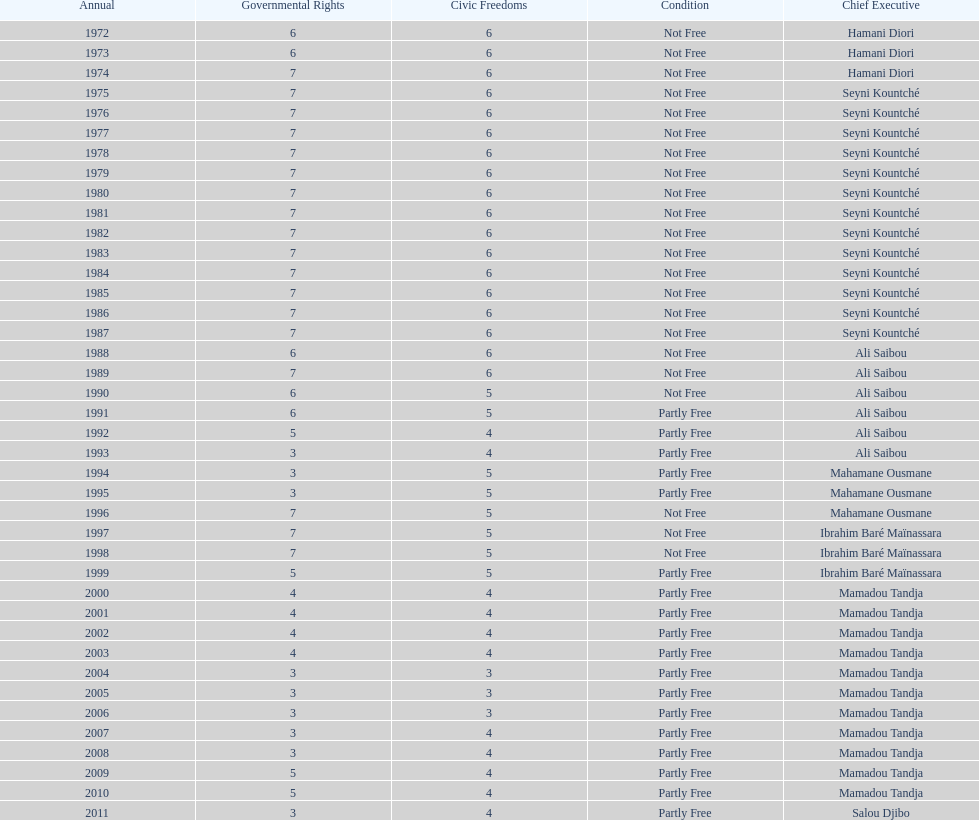How many times was the political rights listed as seven? 18. 